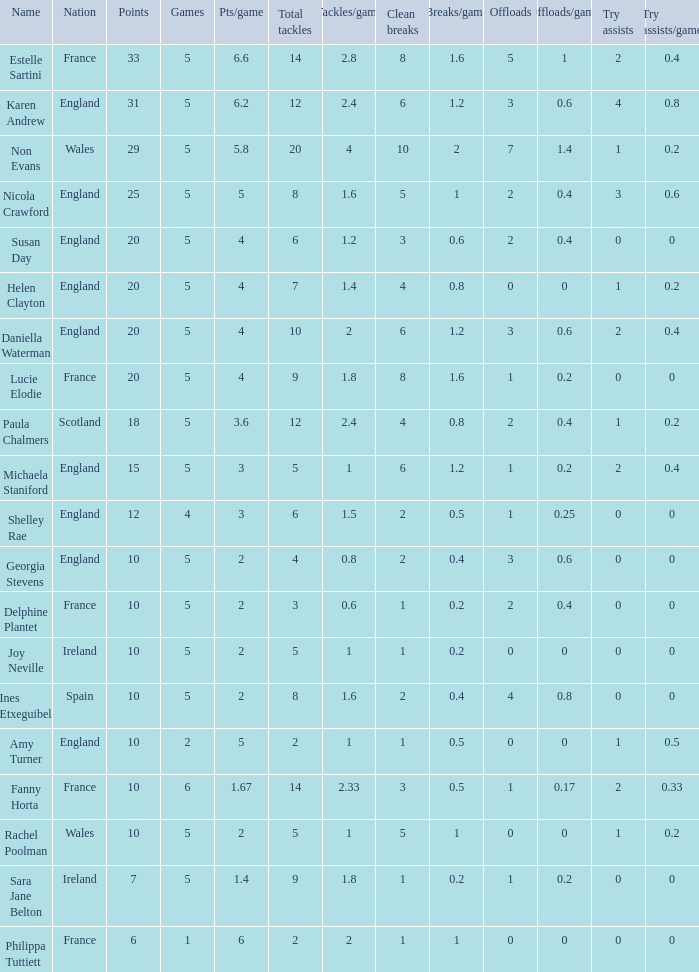Can you tell me the lowest Pts/game that has the Name of philippa tuttiett, and the Points larger then 6? None. 